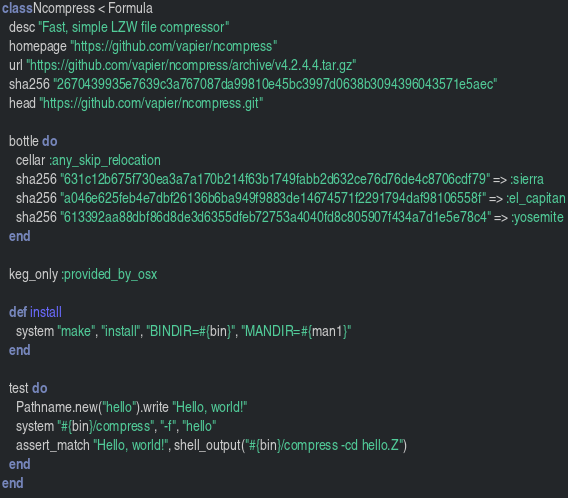<code> <loc_0><loc_0><loc_500><loc_500><_Ruby_>class Ncompress < Formula
  desc "Fast, simple LZW file compressor"
  homepage "https://github.com/vapier/ncompress"
  url "https://github.com/vapier/ncompress/archive/v4.2.4.4.tar.gz"
  sha256 "2670439935e7639c3a767087da99810e45bc3997d0638b3094396043571e5aec"
  head "https://github.com/vapier/ncompress.git"

  bottle do
    cellar :any_skip_relocation
    sha256 "631c12b675f730ea3a7a170b214f63b1749fabb2d632ce76d76de4c8706cdf79" => :sierra
    sha256 "a046e625feb4e7dbf26136b6ba949f9883de14674571f2291794daf98106558f" => :el_capitan
    sha256 "613392aa88dbf86d8de3d6355dfeb72753a4040fd8c805907f434a7d1e5e78c4" => :yosemite
  end

  keg_only :provided_by_osx

  def install
    system "make", "install", "BINDIR=#{bin}", "MANDIR=#{man1}"
  end

  test do
    Pathname.new("hello").write "Hello, world!"
    system "#{bin}/compress", "-f", "hello"
    assert_match "Hello, world!", shell_output("#{bin}/compress -cd hello.Z")
  end
end
</code> 